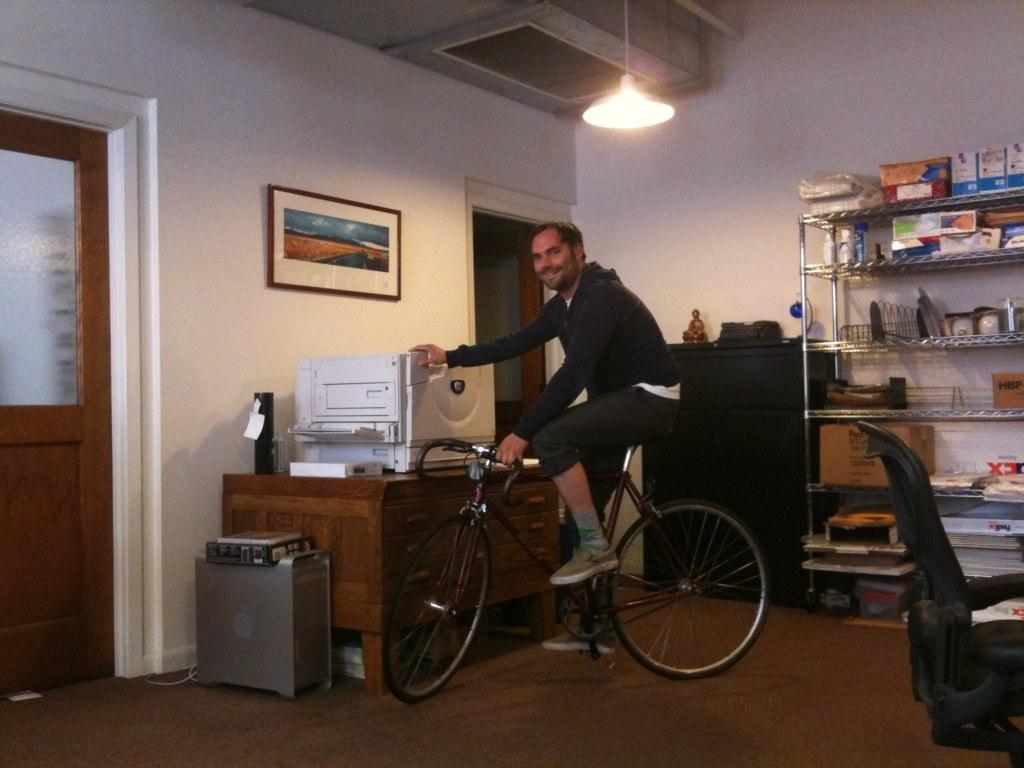What is the main setting of the image? There is a room in the image. What is the person in the image doing? The person is sitting on a bicycle and holding a scanner. What can be seen in the background of the room? There is a photo frame, a window, a cupboard, a table, and a light in the background. What type of boat can be seen sailing in the background of the image? There is no boat present in the image; it is set in a room with various objects and features in the background. How does the person in the image express their happiness? The image does not show the person's emotions, so it cannot be determined if they are expressing happiness or any other emotion. 